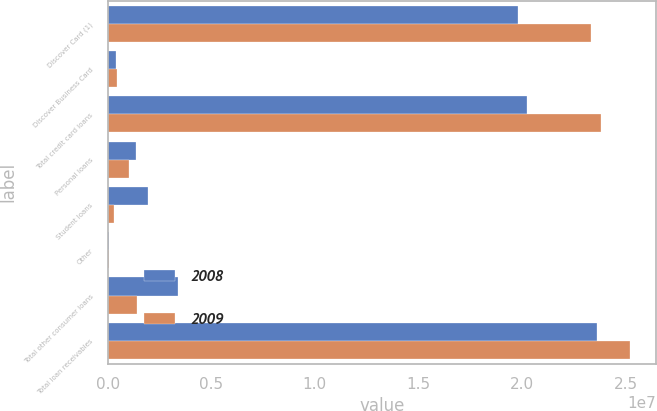Convert chart to OTSL. <chart><loc_0><loc_0><loc_500><loc_500><stacked_bar_chart><ecel><fcel>Discover Card (1)<fcel>Discover Business Card<fcel>Total credit card loans<fcel>Personal loans<fcel>Student loans<fcel>Other<fcel>Total other consumer loans<fcel>Total loan receivables<nl><fcel>2008<fcel>1.98262e+07<fcel>404149<fcel>2.02303e+07<fcel>1.39438e+06<fcel>1.93227e+06<fcel>68137<fcel>3.39478e+06<fcel>2.36251e+07<nl><fcel>2009<fcel>2.33481e+07<fcel>466173<fcel>2.38143e+07<fcel>1.02809e+06<fcel>299929<fcel>74282<fcel>1.4023e+06<fcel>2.52166e+07<nl></chart> 